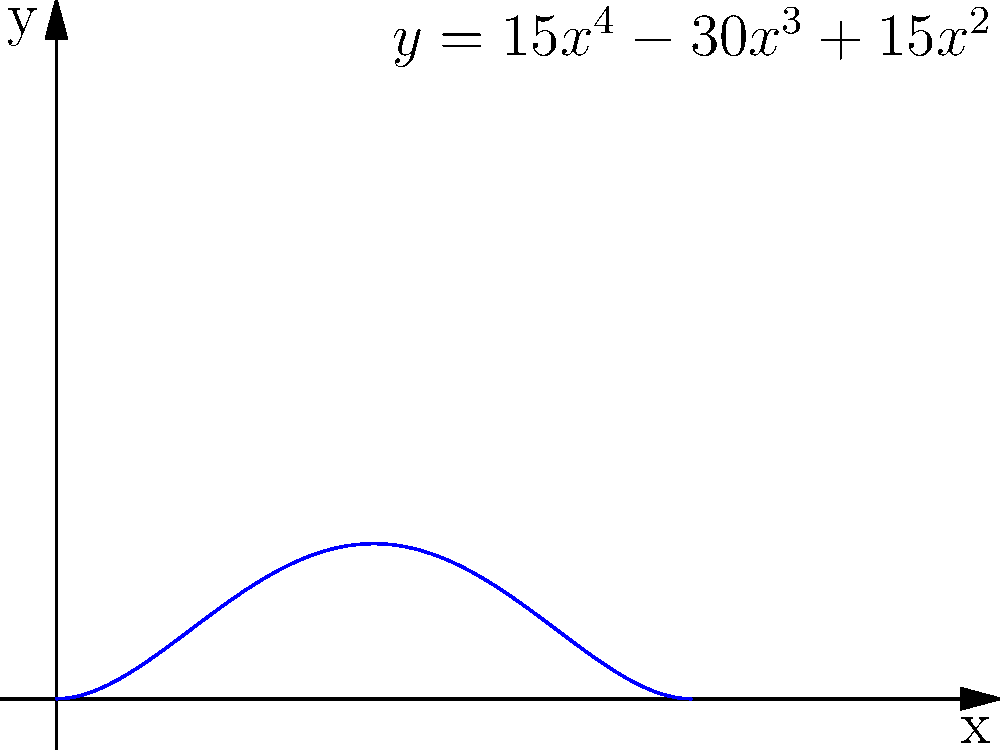The graph above represents the probability distribution of inheriting certain IVs (Individual Values) from parent Pokémon during breeding. If $x$ represents the proportion of IVs inherited from one parent (ranging from 0 to 1), and $y$ represents the probability density, what is the probability of inheriting exactly half of the IVs from each parent? To find the probability of inheriting exactly half of the IVs from each parent, we need to follow these steps:

1) The given function is $y = 15x^4 - 30x^3 + 15x^2$

2) We're interested in the case where $x = 0.5$, as this represents inheriting half of the IVs from each parent.

3) Substitute $x = 0.5$ into the equation:

   $y = 15(0.5)^4 - 30(0.5)^3 + 15(0.5)^2$

4) Simplify:
   $y = 15(0.0625) - 30(0.125) + 15(0.25)$
   $y = 0.9375 - 3.75 + 3.75$
   $y = 0.9375$

5) The y-value at $x = 0.5$ is 0.9375, which represents the probability density at that point.

6) In a probability density function, the actual probability is represented by the area under the curve. However, for a single point, this area is infinitesimally small.

Therefore, the probability of inheriting exactly half of the IVs from each parent is effectively 0, despite the non-zero probability density at that point.
Answer: 0 